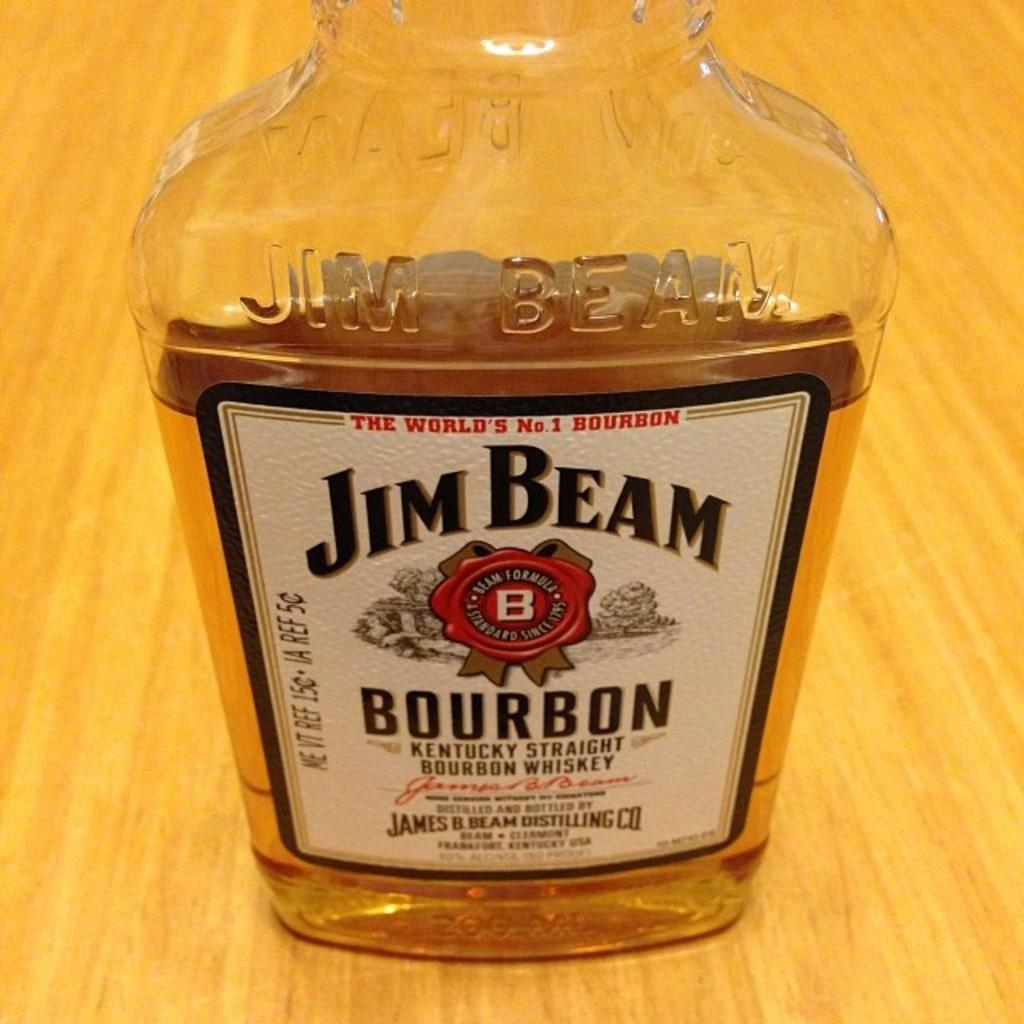What object is present in the image that is made of glass? There is a glass bottle in the image. What is inside the glass bottle? The glass bottle contains Jim beam whiskey. Where is the glass bottle located? The glass bottle is present on a table. Can you see a sofa in the image? There is no sofa present in the image. Are there any fish visible in the image? There are no fish present in the image. Is there a fireman in the image? There is no fireman present in the image. 